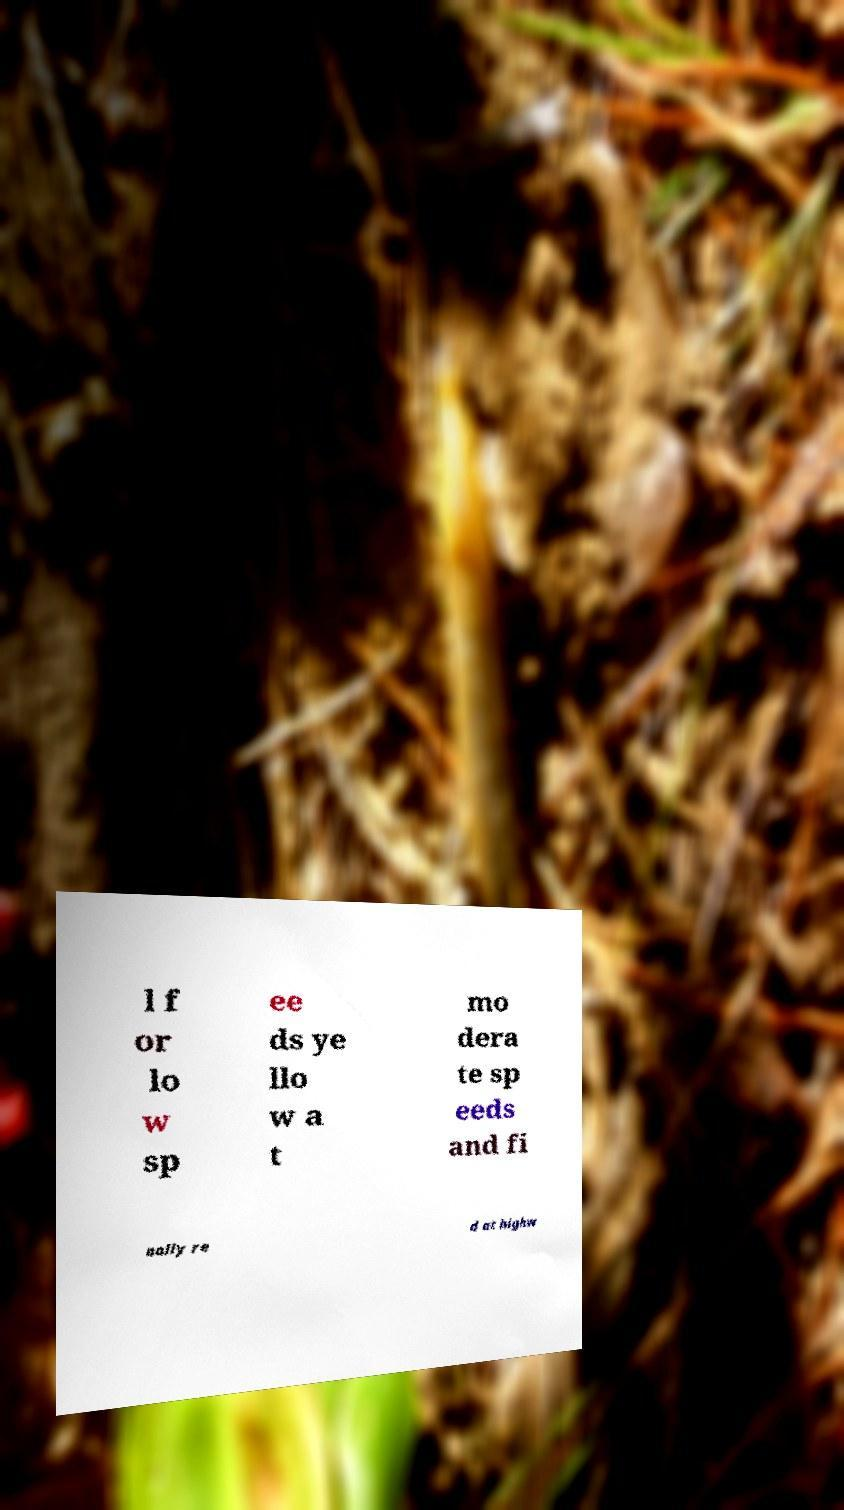Please read and relay the text visible in this image. What does it say? l f or lo w sp ee ds ye llo w a t mo dera te sp eeds and fi nally re d at highw 